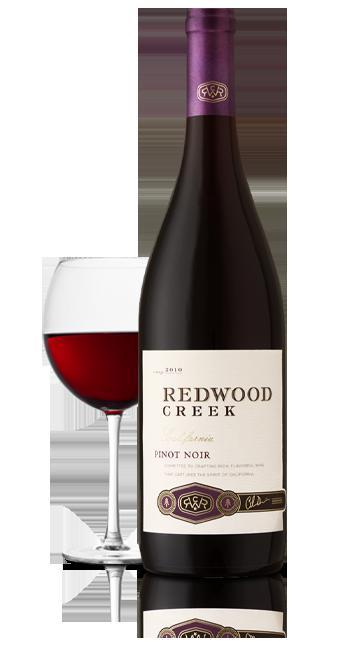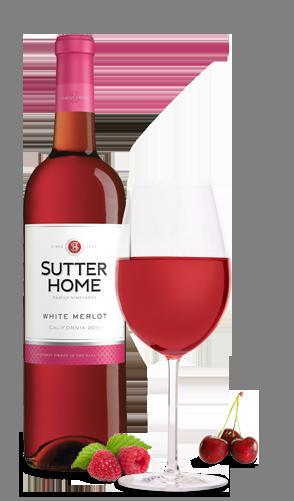The first image is the image on the left, the second image is the image on the right. Assess this claim about the two images: "A total of two wine bottles are depicted.". Correct or not? Answer yes or no. Yes. 